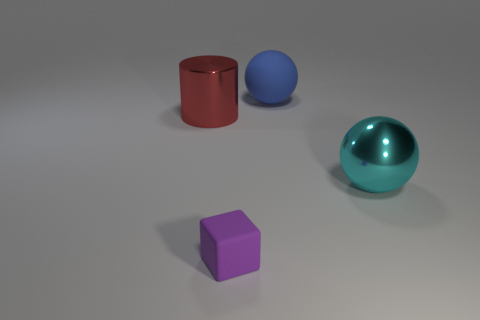Add 3 purple rubber objects. How many objects exist? 7 Subtract all cubes. How many objects are left? 3 Subtract 0 gray blocks. How many objects are left? 4 Subtract all small cyan matte cylinders. Subtract all cyan metal things. How many objects are left? 3 Add 3 tiny purple rubber cubes. How many tiny purple rubber cubes are left? 4 Add 1 small purple things. How many small purple things exist? 2 